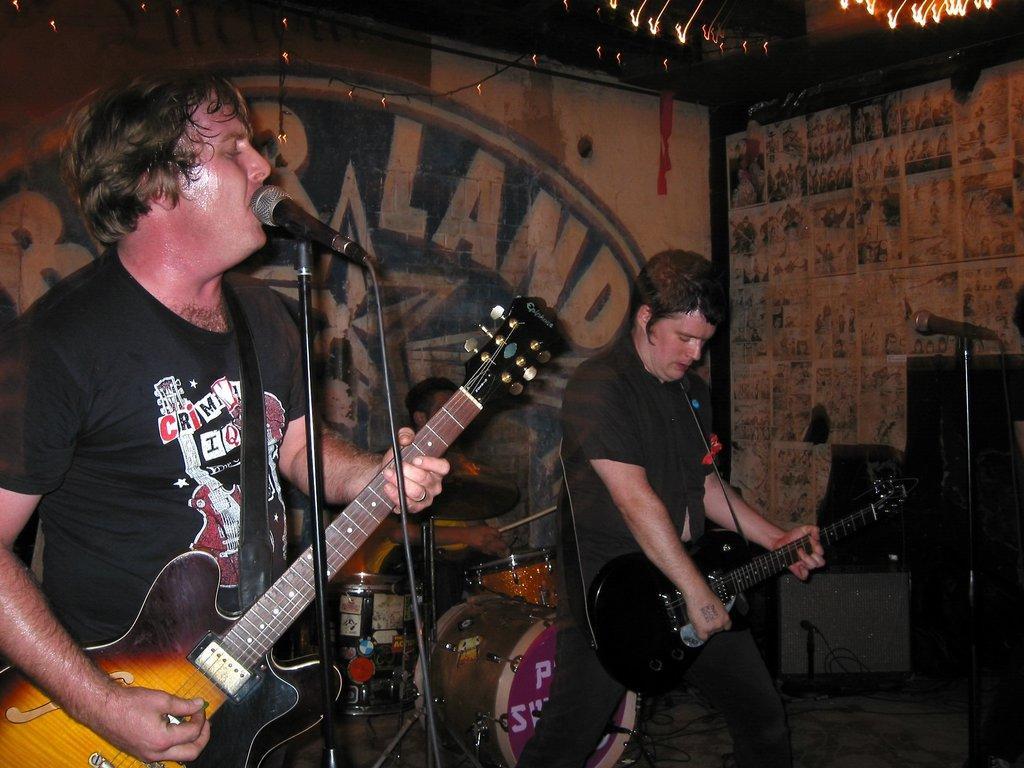How would you summarize this image in a sentence or two? In this image i can see there are two men who are playing a guitar in front of a microphone. 